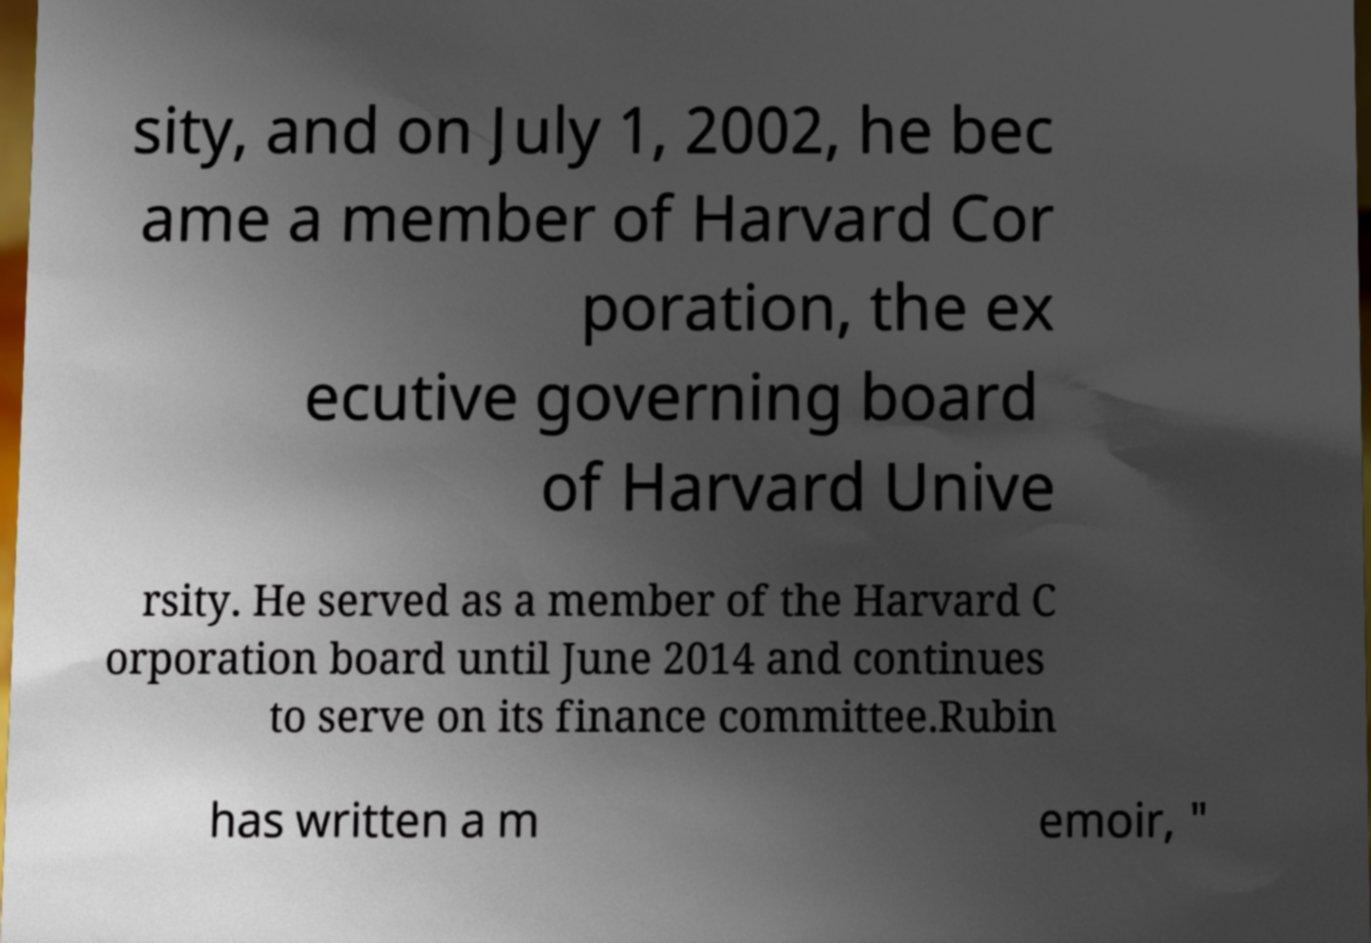I need the written content from this picture converted into text. Can you do that? sity, and on July 1, 2002, he bec ame a member of Harvard Cor poration, the ex ecutive governing board of Harvard Unive rsity. He served as a member of the Harvard C orporation board until June 2014 and continues to serve on its finance committee.Rubin has written a m emoir, " 